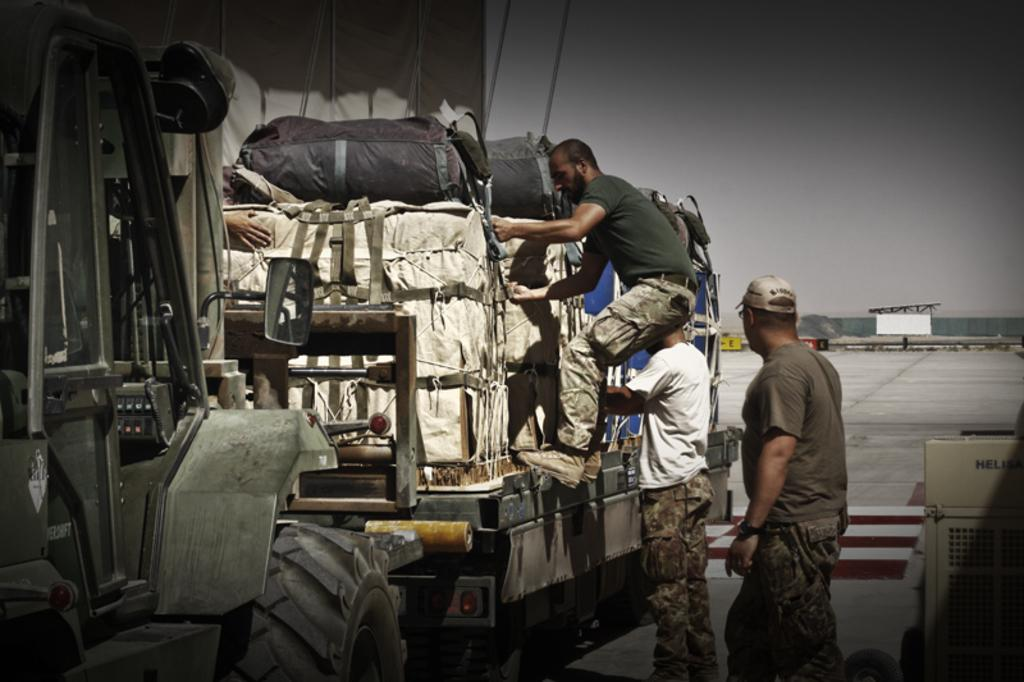What is the main subject of the image? The main subject of the image is a vehicle. What is on the vehicle in the image? The vehicle has luggage on it. How many people are in the image? There are three persons in the image. Can you describe the appearance of one of the persons? One person is wearing a cap. What can be seen in the background of the image? There is sky visible in the background of the image. What type of camera can be seen hanging from the wire in the image? There is no camera or wire present in the image. What is the value of the item being transported by the vehicle in the image? The value of the item being transported by the vehicle cannot be determined from the image. 